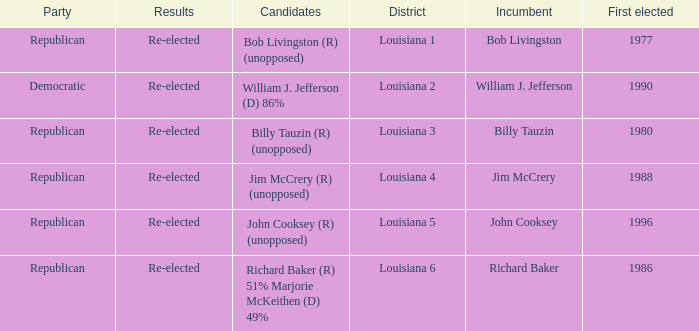Write the full table. {'header': ['Party', 'Results', 'Candidates', 'District', 'Incumbent', 'First elected'], 'rows': [['Republican', 'Re-elected', 'Bob Livingston (R) (unopposed)', 'Louisiana 1', 'Bob Livingston', '1977'], ['Democratic', 'Re-elected', 'William J. Jefferson (D) 86%', 'Louisiana 2', 'William J. Jefferson', '1990'], ['Republican', 'Re-elected', 'Billy Tauzin (R) (unopposed)', 'Louisiana 3', 'Billy Tauzin', '1980'], ['Republican', 'Re-elected', 'Jim McCrery (R) (unopposed)', 'Louisiana 4', 'Jim McCrery', '1988'], ['Republican', 'Re-elected', 'John Cooksey (R) (unopposed)', 'Louisiana 5', 'John Cooksey', '1996'], ['Republican', 'Re-elected', 'Richard Baker (R) 51% Marjorie McKeithen (D) 49%', 'Louisiana 6', 'Richard Baker', '1986']]} How many candidates were elected first in 1980? 1.0. 